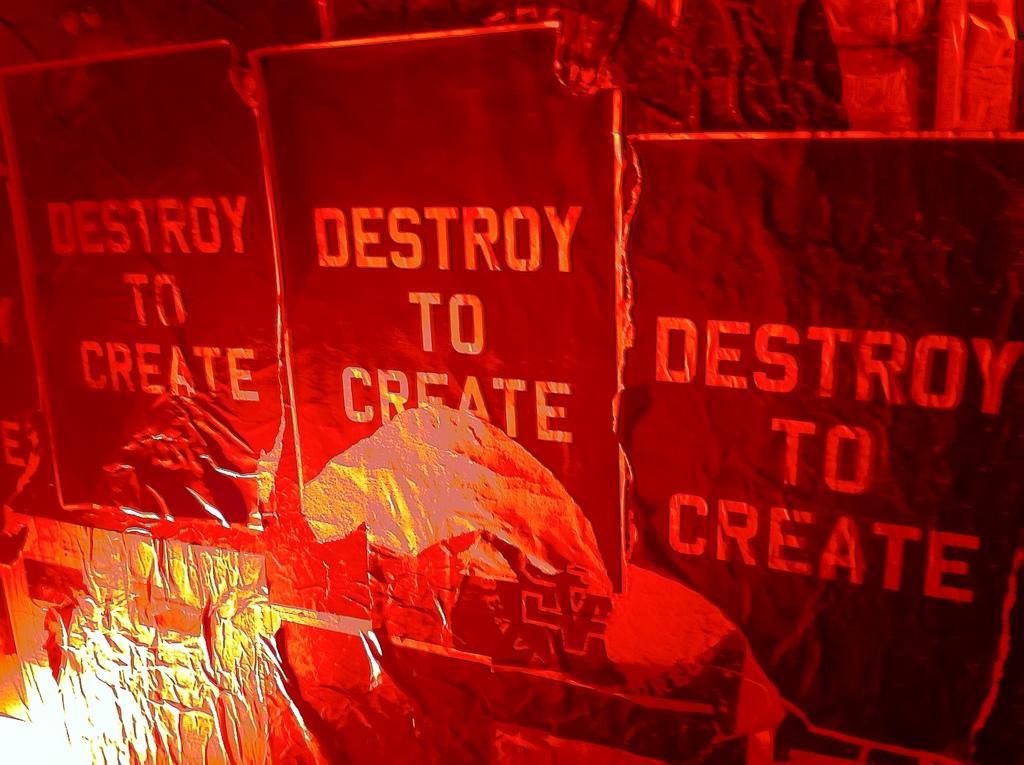How would you summarize this image in a sentence or two? In this image we can see advertisements. 